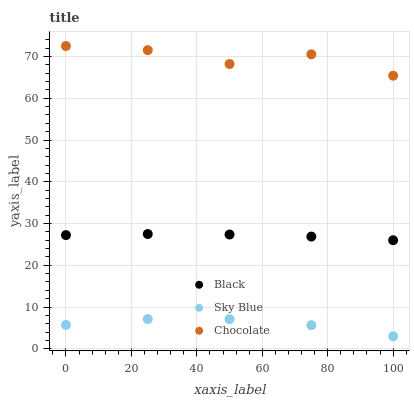Does Sky Blue have the minimum area under the curve?
Answer yes or no. Yes. Does Chocolate have the maximum area under the curve?
Answer yes or no. Yes. Does Black have the minimum area under the curve?
Answer yes or no. No. Does Black have the maximum area under the curve?
Answer yes or no. No. Is Black the smoothest?
Answer yes or no. Yes. Is Chocolate the roughest?
Answer yes or no. Yes. Is Chocolate the smoothest?
Answer yes or no. No. Is Black the roughest?
Answer yes or no. No. Does Sky Blue have the lowest value?
Answer yes or no. Yes. Does Black have the lowest value?
Answer yes or no. No. Does Chocolate have the highest value?
Answer yes or no. Yes. Does Black have the highest value?
Answer yes or no. No. Is Sky Blue less than Black?
Answer yes or no. Yes. Is Chocolate greater than Sky Blue?
Answer yes or no. Yes. Does Sky Blue intersect Black?
Answer yes or no. No. 